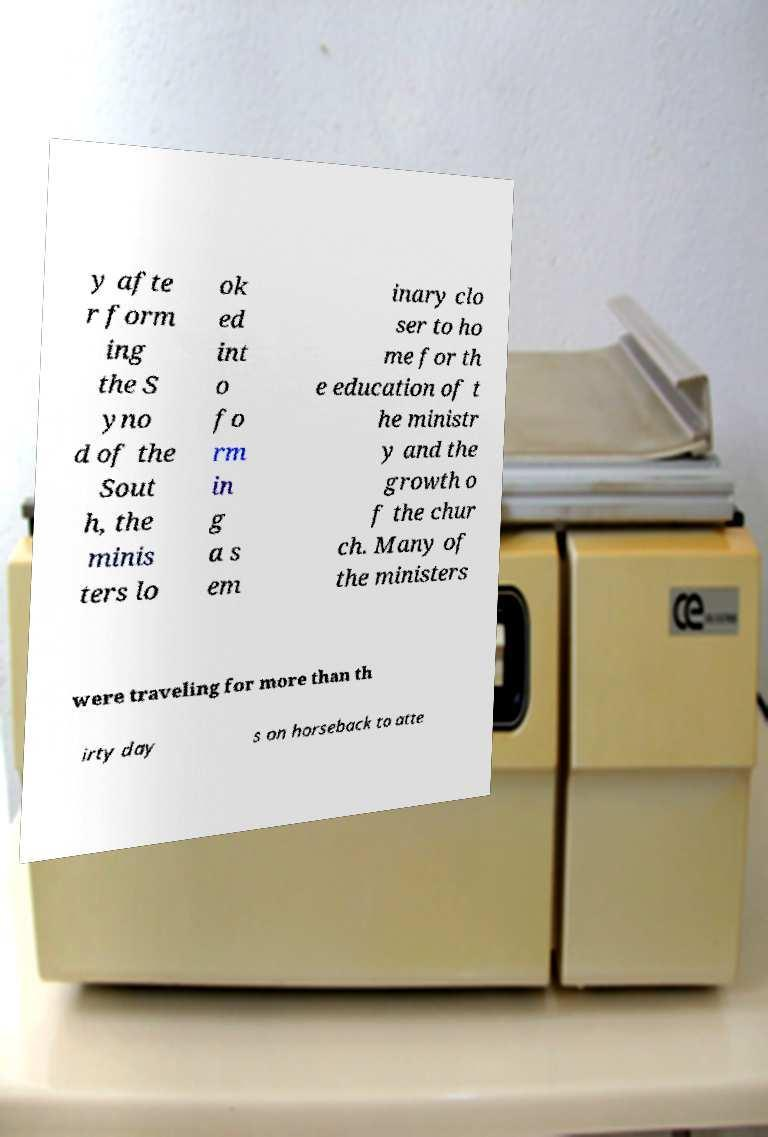I need the written content from this picture converted into text. Can you do that? y afte r form ing the S yno d of the Sout h, the minis ters lo ok ed int o fo rm in g a s em inary clo ser to ho me for th e education of t he ministr y and the growth o f the chur ch. Many of the ministers were traveling for more than th irty day s on horseback to atte 